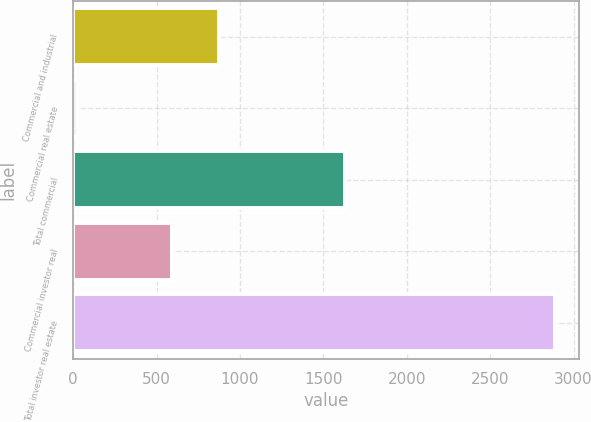Convert chart to OTSL. <chart><loc_0><loc_0><loc_500><loc_500><bar_chart><fcel>Commercial and industrial<fcel>Commercial real estate<fcel>Total commercial<fcel>Commercial investor real<fcel>Total investor real estate<nl><fcel>875.7<fcel>23<fcel>1628<fcel>589<fcel>2890<nl></chart> 